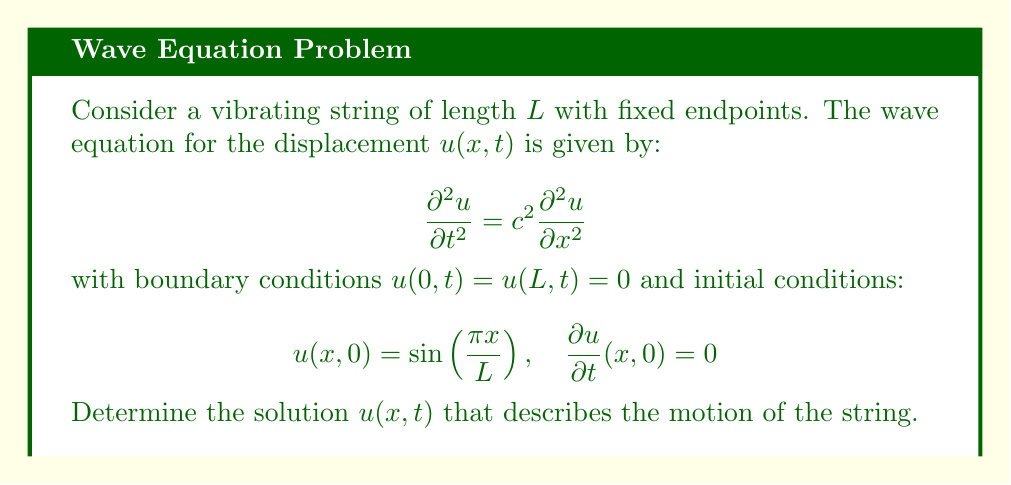Give your solution to this math problem. 1) Given the wave equation and boundary conditions, we can use the method of separation of variables. Let $u(x,t) = X(x)T(t)$.

2) Substituting into the wave equation:
   $$X(x)T''(t) = c^2X''(x)T(t)$$
   $$\frac{T''(t)}{c^2T(t)} = \frac{X''(x)}{X(x)} = -k^2$$

3) This leads to two ODEs:
   $$X''(x) + k^2X(x) = 0$$
   $$T''(t) + c^2k^2T(t) = 0$$

4) Solving the spatial ODE with boundary conditions:
   $$X(x) = A\sin(kx), \quad k = \frac{n\pi}{L}, \quad n = 1,2,3,...$$

5) The temporal ODE solution is:
   $$T(t) = B\cos(c k t) + C\sin(c k t)$$

6) The general solution is:
   $$u(x,t) = \sum_{n=1}^{\infty} [B_n\cos(\frac{n\pi c t}{L}) + C_n\sin(\frac{n\pi c t}{L})]\sin(\frac{n\pi x}{L})$$

7) Applying the initial conditions:
   $$u(x,0) = \sin(\frac{\pi x}{L}) = \sum_{n=1}^{\infty} B_n\sin(\frac{n\pi x}{L})$$
   This implies $B_1 = 1$ and $B_n = 0$ for $n > 1$.

8) For the initial velocity condition:
   $$\frac{\partial u}{\partial t}(x,0) = 0 = \sum_{n=1}^{\infty} C_n\frac{n\pi c}{L}\sin(\frac{n\pi x}{L})$$
   This implies $C_n = 0$ for all $n$.

9) Therefore, the solution is:
   $$u(x,t) = \sin(\frac{\pi x}{L})\cos(\frac{\pi c t}{L})$$
Answer: $u(x,t) = \sin(\frac{\pi x}{L})\cos(\frac{\pi c t}{L})$ 